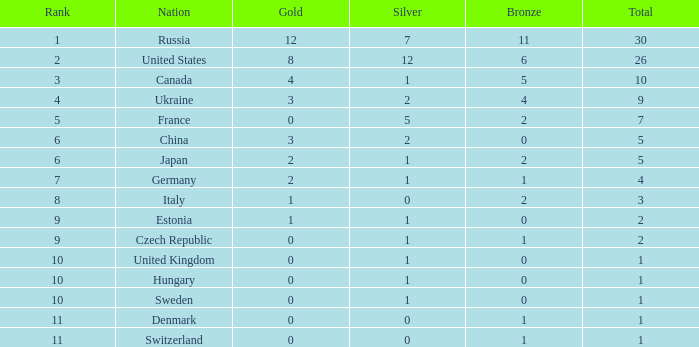What is the largest silver with Gold larger than 4, a Nation of united states, and a Total larger than 26? None. 